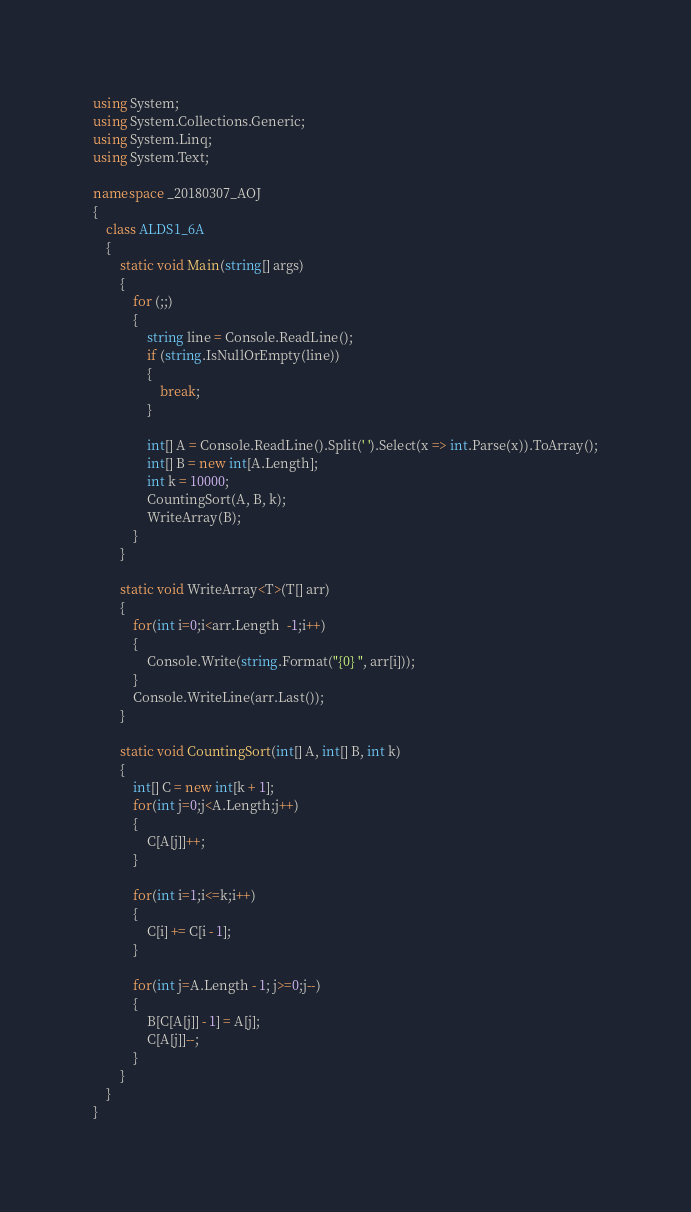Convert code to text. <code><loc_0><loc_0><loc_500><loc_500><_C#_>using System;
using System.Collections.Generic;
using System.Linq;
using System.Text;

namespace _20180307_AOJ
{
    class ALDS1_6A
    {
        static void Main(string[] args)
        {
            for (;;)
            {
                string line = Console.ReadLine();
                if (string.IsNullOrEmpty(line))
                {
                    break;
                }

                int[] A = Console.ReadLine().Split(' ').Select(x => int.Parse(x)).ToArray();
                int[] B = new int[A.Length];
                int k = 10000;
                CountingSort(A, B, k);
                WriteArray(B);
            }
        }

        static void WriteArray<T>(T[] arr)
        {
            for(int i=0;i<arr.Length  -1;i++)
            {
                Console.Write(string.Format("{0} ", arr[i]));
            }
            Console.WriteLine(arr.Last());
        }

        static void CountingSort(int[] A, int[] B, int k)
        {
            int[] C = new int[k + 1];
            for(int j=0;j<A.Length;j++)
            {
                C[A[j]]++;
            }

            for(int i=1;i<=k;i++)
            {
                C[i] += C[i - 1];
            }

            for(int j=A.Length - 1; j>=0;j--)
            {
                B[C[A[j]] - 1] = A[j];
                C[A[j]]--;
            }
        }
    }
}

</code> 